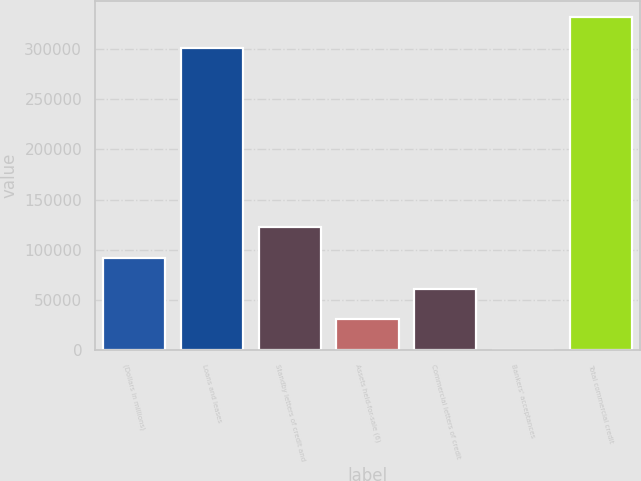Convert chart. <chart><loc_0><loc_0><loc_500><loc_500><bar_chart><fcel>(Dollars in millions)<fcel>Loans and leases<fcel>Standby letters of credit and<fcel>Assets held-for-sale (6)<fcel>Commercial letters of credit<fcel>Bankers' acceptances<fcel>Total commercial credit<nl><fcel>91984<fcel>300856<fcel>122641<fcel>30670<fcel>61327<fcel>13<fcel>331513<nl></chart> 